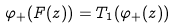<formula> <loc_0><loc_0><loc_500><loc_500>\varphi _ { + } ( F ( z ) ) = T _ { 1 } ( \varphi _ { + } ( z ) )</formula> 